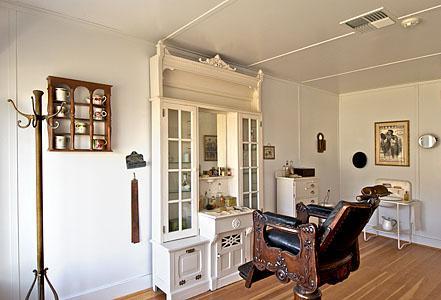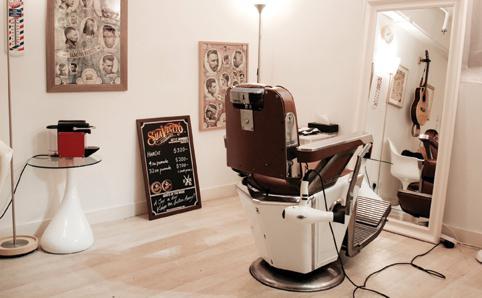The first image is the image on the left, the second image is the image on the right. Examine the images to the left and right. Is the description "Both rooms are empty." accurate? Answer yes or no. Yes. The first image is the image on the left, the second image is the image on the right. For the images shown, is this caption "There are at least two bright red chairs." true? Answer yes or no. No. 